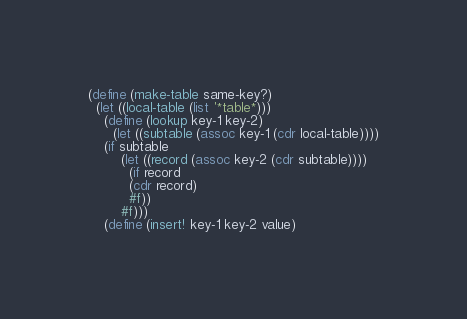Convert code to text. <code><loc_0><loc_0><loc_500><loc_500><_Scheme_>(define (make-table same-key?)
  (let ((local-table (list '*table*)))
    (define (lookup key-1 key-2)
      (let ((subtable (assoc key-1 (cdr local-table))))
	(if subtable
	    (let ((record (assoc key-2 (cdr subtable))))
	      (if record
		  (cdr record)
		  #f))
	    #f)))
    (define (insert! key-1 key-2 value)</code> 